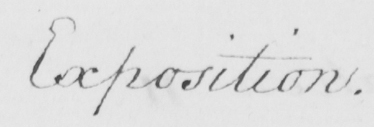Transcribe the text shown in this historical manuscript line. Exposition . 